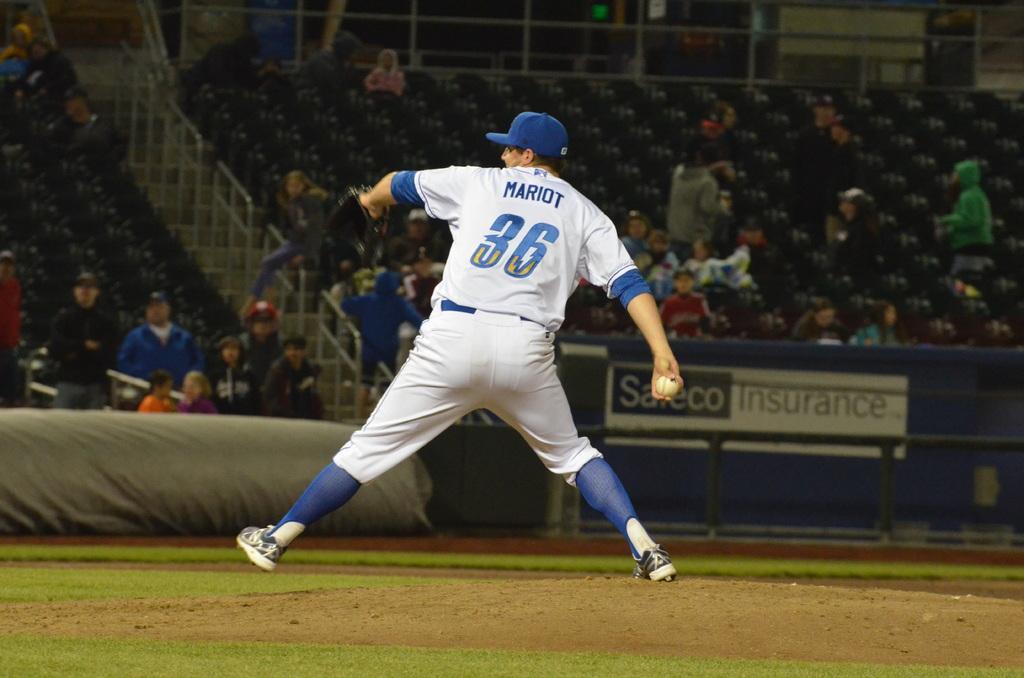Can you describe this image briefly? In this image I can see a person wearing blue and white colored dress is standing and holding a ball in his hand. In the background I can see the stadium, number of persons sitting in the stadium and the railing. 